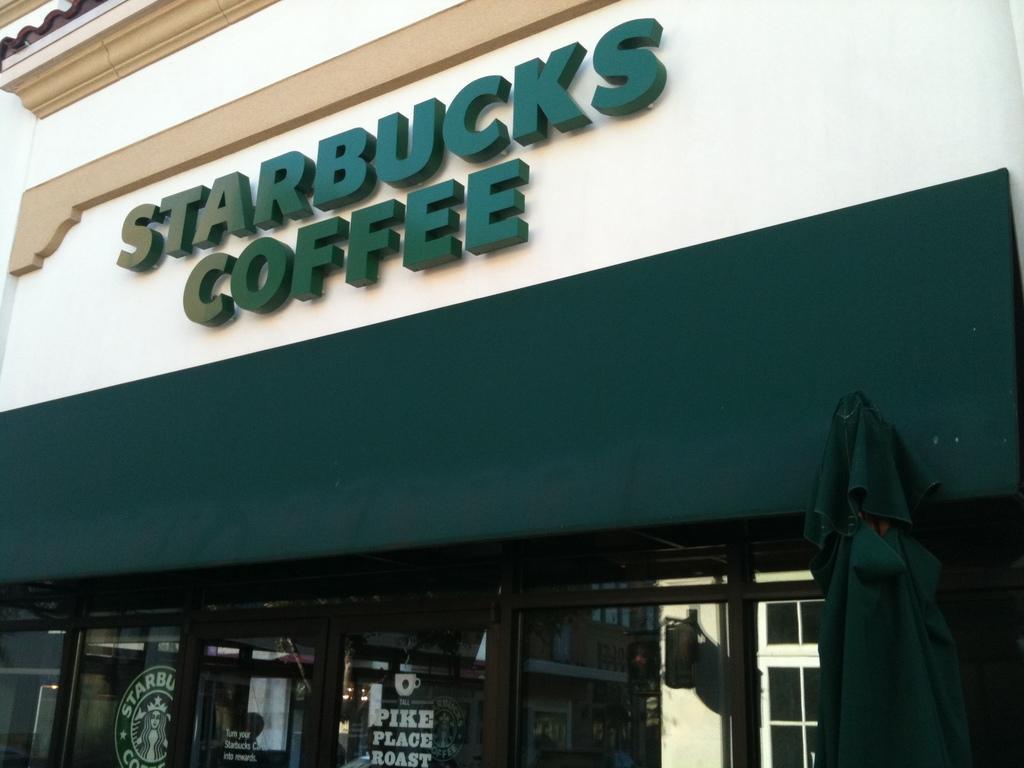Can you describe this image briefly? In this picture, we see a coffee shop. At the bottom of the picture, we see glass doors. In the middle of the picture, we see a building in white and green color. On the building, it is written as "STARBUCKS COFFEE". 